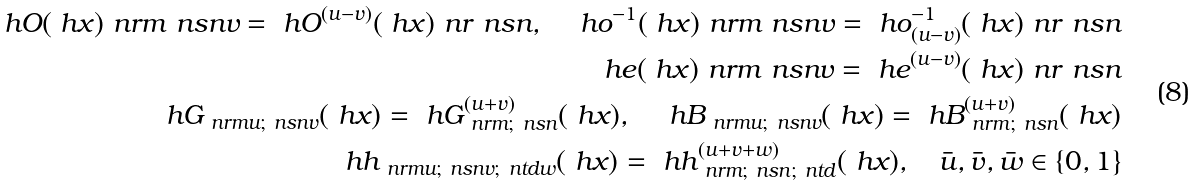Convert formula to latex. <formula><loc_0><loc_0><loc_500><loc_500>\ h O ( \ h x ) _ { \ } n r m ^ { \ } n s n v = \ h O ^ { ( u - v ) } ( \ h x ) _ { \ } n r ^ { \ } n s n , \quad \ h o ^ { - 1 } ( \ h x ) _ { \ } n r m ^ { \ } n s n v = \ h o _ { ( u - v ) } ^ { - 1 } ( \ h x ) _ { \ } n r ^ { \ } n s n \\ \ h e ( \ h x ) _ { \ } n r m ^ { \ } n s n v = \ h e ^ { ( u - v ) } ( \ h x ) _ { \ } n r ^ { \ } n s n \\ \ h G _ { \ n r m u ; \ n s n v } ( \ h x ) = \ h G _ { \ n r m ; \ n s n } ^ { ( u + v ) } ( \ h x ) , \quad \ h B _ { \ n r m u ; \ n s n v } ( \ h x ) = \ h B _ { \ n r m ; \ n s n } ^ { ( u + v ) } ( \ h x ) \\ \ h h _ { \ n r m u ; \ n s n v ; \ n t d w } ( \ h x ) = \ h h _ { \ n r m ; \ n s n ; \ n t d } ^ { ( u + v + w ) } ( \ h x ) , \quad \bar { u } , \bar { v } , \bar { w } \in \{ 0 , 1 \}</formula> 